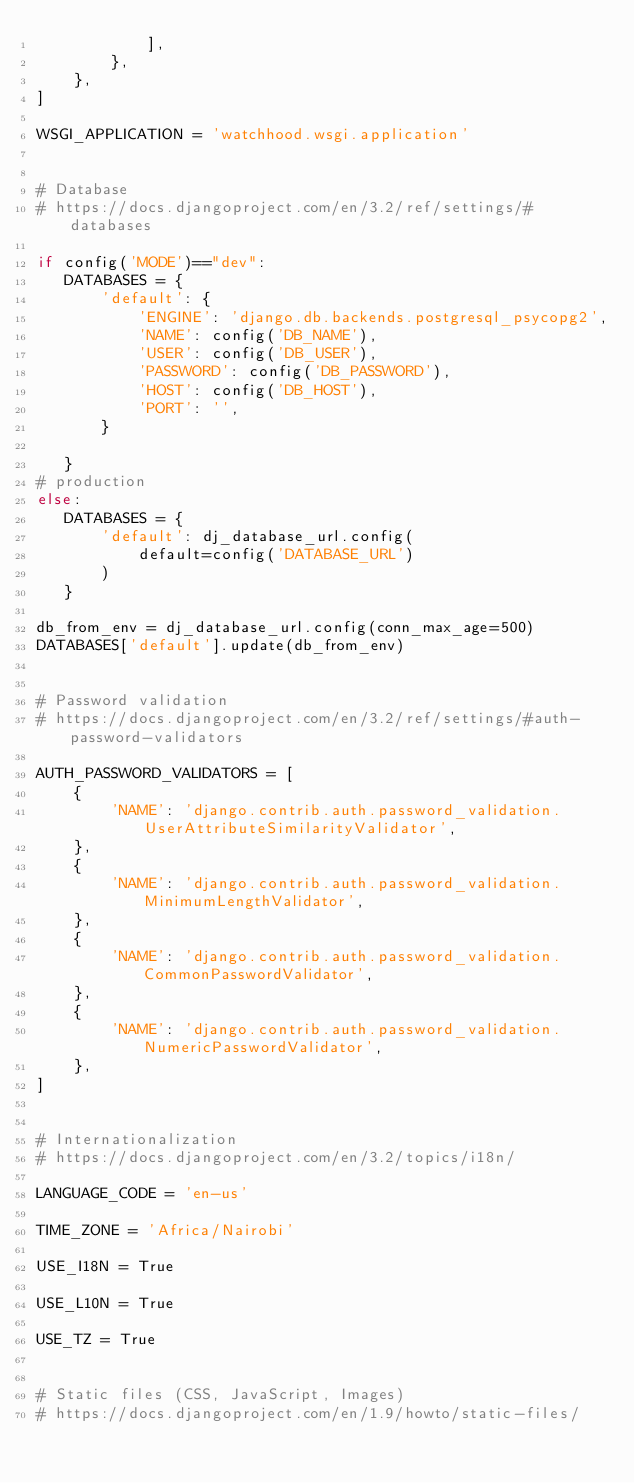Convert code to text. <code><loc_0><loc_0><loc_500><loc_500><_Python_>            ],
        },
    },
]

WSGI_APPLICATION = 'watchhood.wsgi.application'


# Database
# https://docs.djangoproject.com/en/3.2/ref/settings/#databases

if config('MODE')=="dev":
   DATABASES = {
       'default': {
           'ENGINE': 'django.db.backends.postgresql_psycopg2',
           'NAME': config('DB_NAME'),
           'USER': config('DB_USER'),
           'PASSWORD': config('DB_PASSWORD'),
           'HOST': config('DB_HOST'),
           'PORT': '',
       }
       
   }
# production
else:
   DATABASES = {
       'default': dj_database_url.config(
           default=config('DATABASE_URL')
       )
   }

db_from_env = dj_database_url.config(conn_max_age=500)
DATABASES['default'].update(db_from_env)


# Password validation
# https://docs.djangoproject.com/en/3.2/ref/settings/#auth-password-validators

AUTH_PASSWORD_VALIDATORS = [
    {
        'NAME': 'django.contrib.auth.password_validation.UserAttributeSimilarityValidator',
    },
    {
        'NAME': 'django.contrib.auth.password_validation.MinimumLengthValidator',
    },
    {
        'NAME': 'django.contrib.auth.password_validation.CommonPasswordValidator',
    },
    {
        'NAME': 'django.contrib.auth.password_validation.NumericPasswordValidator',
    },
]


# Internationalization
# https://docs.djangoproject.com/en/3.2/topics/i18n/

LANGUAGE_CODE = 'en-us'

TIME_ZONE = 'Africa/Nairobi'

USE_I18N = True

USE_L10N = True

USE_TZ = True


# Static files (CSS, JavaScript, Images)
# https://docs.djangoproject.com/en/1.9/howto/static-files/</code> 